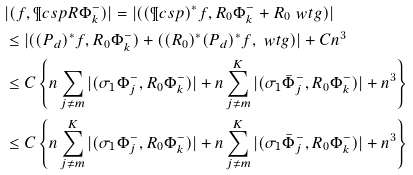Convert formula to latex. <formula><loc_0><loc_0><loc_500><loc_500>& | ( f , \P c s p R \Phi _ { k } ^ { - } ) | = | ( ( \P c s p ) ^ { * } f , R _ { 0 } \Phi _ { k } ^ { - } + R _ { 0 } \ w t { g } ) | \\ & \leq | ( ( P _ { d } ) ^ { * } f , R _ { 0 } \Phi _ { k } ^ { - } ) + ( ( R _ { 0 } ) ^ { * } ( P _ { d } ) ^ { * } f , \ w t { g } ) | + C n ^ { 3 } \\ & \leq C \left \{ n \sum _ { j \not = m } | ( \sigma _ { 1 } \Phi _ { j } ^ { - } , R _ { 0 } \Phi _ { k } ^ { - } ) | + n \sum _ { j \not = m } ^ { K } | ( \sigma _ { 1 } \bar { \Phi } _ { j } ^ { - } , R _ { 0 } \Phi _ { k } ^ { - } ) | + n ^ { 3 } \right \} \\ & \leq C \left \{ n \sum _ { j \not = m } ^ { K } | ( \sigma _ { 1 } \Phi _ { j } ^ { - } , R _ { 0 } \Phi _ { k } ^ { - } ) | + n \sum _ { j \not = m } ^ { K } | ( \sigma _ { 1 } \bar { \Phi } _ { j } ^ { - } , R _ { 0 } \Phi _ { k } ^ { - } ) | + n ^ { 3 } \right \}</formula> 